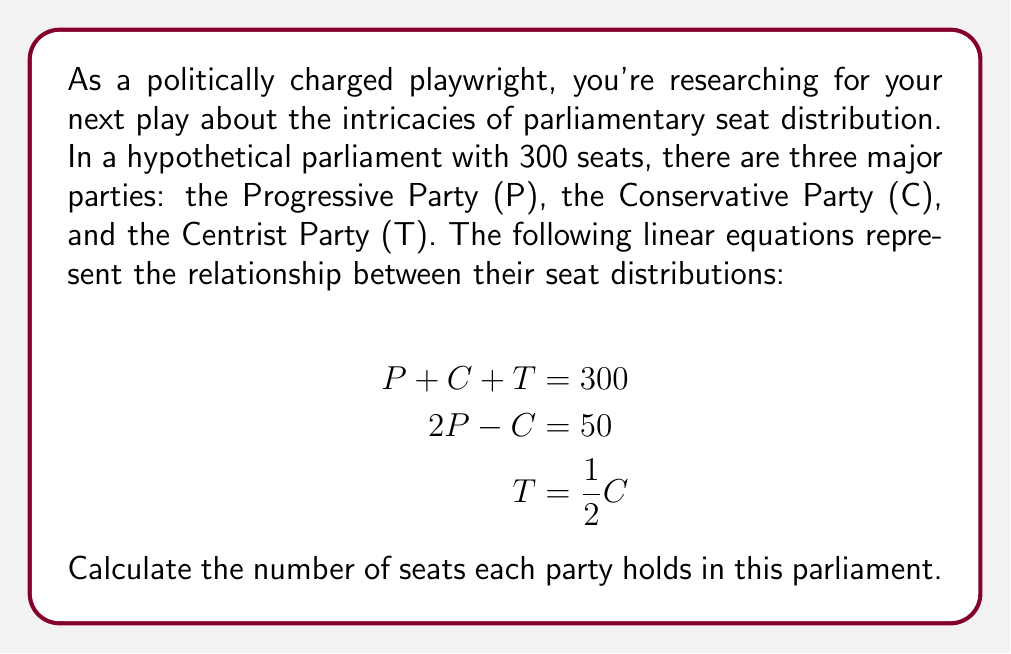Provide a solution to this math problem. Let's solve this system of linear equations step by step:

1) We have three equations:
   $$P + C + T = 300$$ (Equation 1)
   $$2P - C = 50$$ (Equation 2)
   $$T = \frac{1}{2}C$$ (Equation 3)

2) From Equation 3, we can substitute $T$ into Equation 1:
   $$P + C + \frac{1}{2}C = 300$$
   $$P + \frac{3}{2}C = 300$$ (Equation 4)

3) From Equation 2, we can express $P$ in terms of $C$:
   $$2P = 50 + C$$
   $$P = 25 + \frac{1}{2}C$$ (Equation 5)

4) Now, substitute Equation 5 into Equation 4:
   $$(25 + \frac{1}{2}C) + \frac{3}{2}C = 300$$
   $$25 + 2C = 300$$
   $$2C = 275$$
   $$C = 137.5$$

5) Since we can't have half a seat, we round down to $C = 137$ (Conservative Party seats)

6) Using Equation 5, we can now calculate $P$:
   $$P = 25 + \frac{1}{2}(137) = 25 + 68.5 = 93.5$$
   Rounding up, $P = 94$ (Progressive Party seats)

7) Using Equation 3, we can calculate $T$:
   $$T = \frac{1}{2}(137) = 68.5$$
   Rounding up, $T = 69$ (Centrist Party seats)

8) Verify: $94 + 137 + 69 = 300$, which satisfies Equation 1.
Answer: Progressive Party (P): 94 seats
Conservative Party (C): 137 seats
Centrist Party (T): 69 seats 